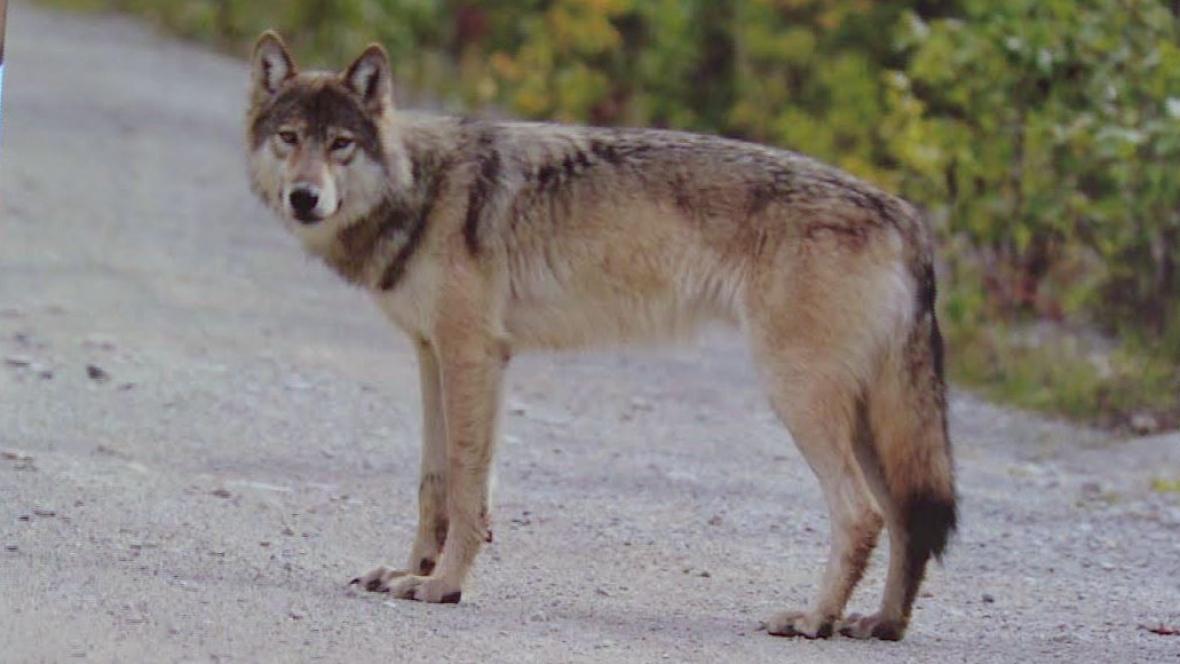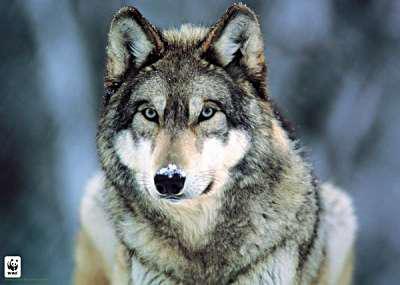The first image is the image on the left, the second image is the image on the right. Analyze the images presented: Is the assertion "At least one of the wolves is visibly standing on snow." valid? Answer yes or no. No. 